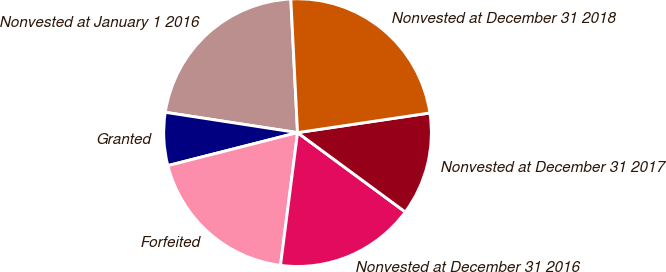<chart> <loc_0><loc_0><loc_500><loc_500><pie_chart><fcel>Nonvested at January 1 2016<fcel>Granted<fcel>Forfeited<fcel>Nonvested at December 31 2016<fcel>Nonvested at December 31 2017<fcel>Nonvested at December 31 2018<nl><fcel>21.77%<fcel>6.39%<fcel>19.0%<fcel>16.93%<fcel>12.45%<fcel>23.45%<nl></chart> 